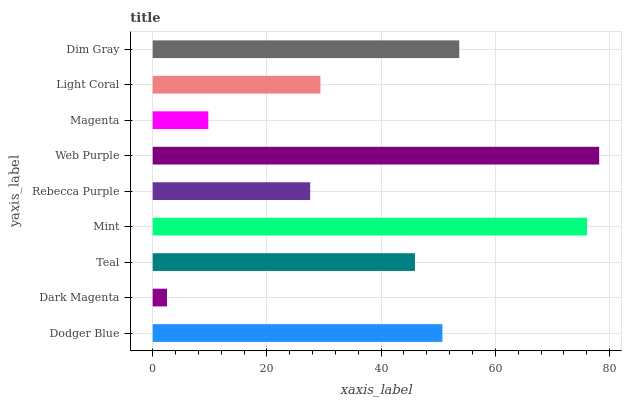Is Dark Magenta the minimum?
Answer yes or no. Yes. Is Web Purple the maximum?
Answer yes or no. Yes. Is Teal the minimum?
Answer yes or no. No. Is Teal the maximum?
Answer yes or no. No. Is Teal greater than Dark Magenta?
Answer yes or no. Yes. Is Dark Magenta less than Teal?
Answer yes or no. Yes. Is Dark Magenta greater than Teal?
Answer yes or no. No. Is Teal less than Dark Magenta?
Answer yes or no. No. Is Teal the high median?
Answer yes or no. Yes. Is Teal the low median?
Answer yes or no. Yes. Is Dim Gray the high median?
Answer yes or no. No. Is Mint the low median?
Answer yes or no. No. 